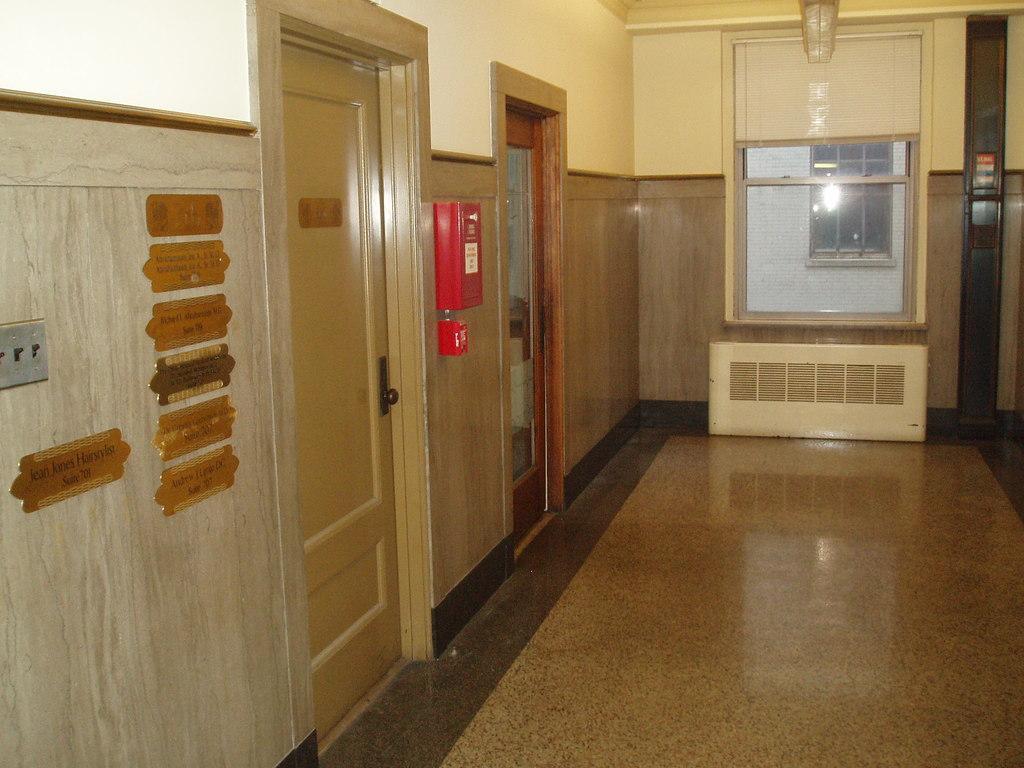How would you summarize this image in a sentence or two? This picture shows an inner view of a building. There is one name plate is attached to the wooden door, one glass door, one glass window, some objects is attached to the wall and some nameplates attached to the wall. One object on the surface. One fire extinguisher hanging on the wall. 